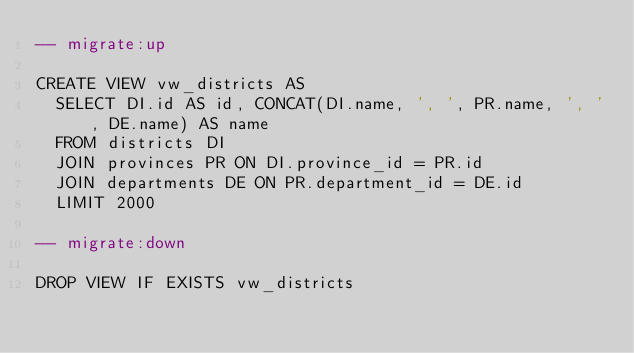Convert code to text. <code><loc_0><loc_0><loc_500><loc_500><_SQL_>-- migrate:up

CREATE VIEW vw_districts AS
  SELECT DI.id AS id, CONCAT(DI.name, ', ', PR.name, ', ', DE.name) AS name
  FROM districts DI
  JOIN provinces PR ON DI.province_id = PR.id
  JOIN departments DE ON PR.department_id = DE.id
  LIMIT 2000

-- migrate:down

DROP VIEW IF EXISTS vw_districts</code> 